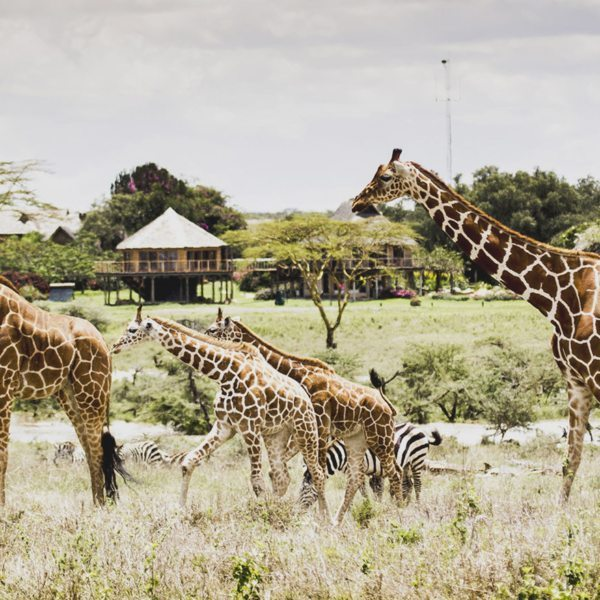Do you see any signs of seasonal changes in this image? How does this aspect influence the wildlife present? Yes, the image suggests a dry season with the yellowish grass and clear skies. During the dry season, water becomes scarce, and wildlife tends to congregate around remaining water sources. This increases competition for food and water among herbivores and can make them more vulnerable to predators. Conversely, the approaching wet season would transform the landscape into a greener, more lush environment, improving food availability and supporting new births. Seasonal changes are crucial in the savanna, dictating the movement patterns, survival strategies, and reproductive cycles of the wildlife. 